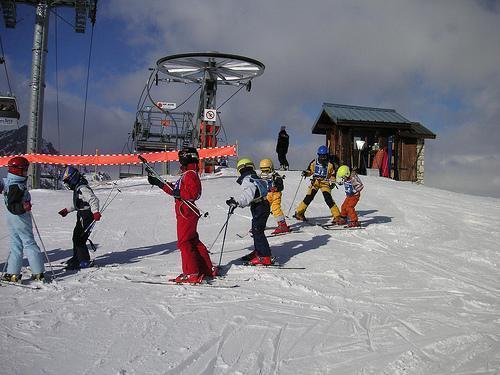How many people are there?
Give a very brief answer. 8. 